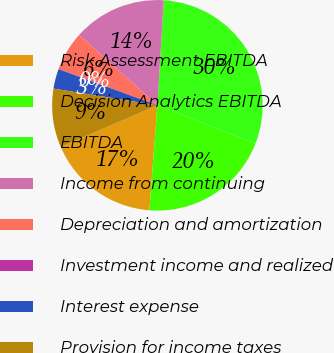<chart> <loc_0><loc_0><loc_500><loc_500><pie_chart><fcel>Risk Assessment EBITDA<fcel>Decision Analytics EBITDA<fcel>EBITDA<fcel>Income from continuing<fcel>Depreciation and amortization<fcel>Investment income and realized<fcel>Interest expense<fcel>Provision for income taxes<nl><fcel>17.3%<fcel>20.29%<fcel>29.96%<fcel>14.31%<fcel>6.03%<fcel>0.04%<fcel>3.04%<fcel>9.02%<nl></chart> 